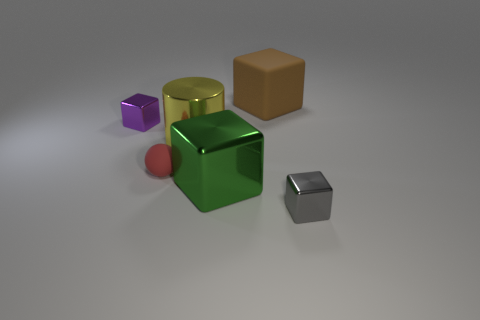Subtract 3 blocks. How many blocks are left? 1 Subtract all purple shiny cubes. How many cubes are left? 3 Subtract all brown cubes. How many cubes are left? 3 Subtract all blocks. How many objects are left? 2 Add 4 yellow cylinders. How many yellow cylinders are left? 5 Add 3 gray objects. How many gray objects exist? 4 Add 2 tiny matte balls. How many objects exist? 8 Subtract 0 red cylinders. How many objects are left? 6 Subtract all red cubes. Subtract all yellow cylinders. How many cubes are left? 4 Subtract all blue cylinders. How many yellow blocks are left? 0 